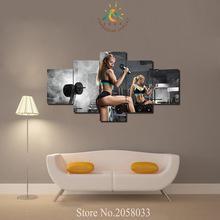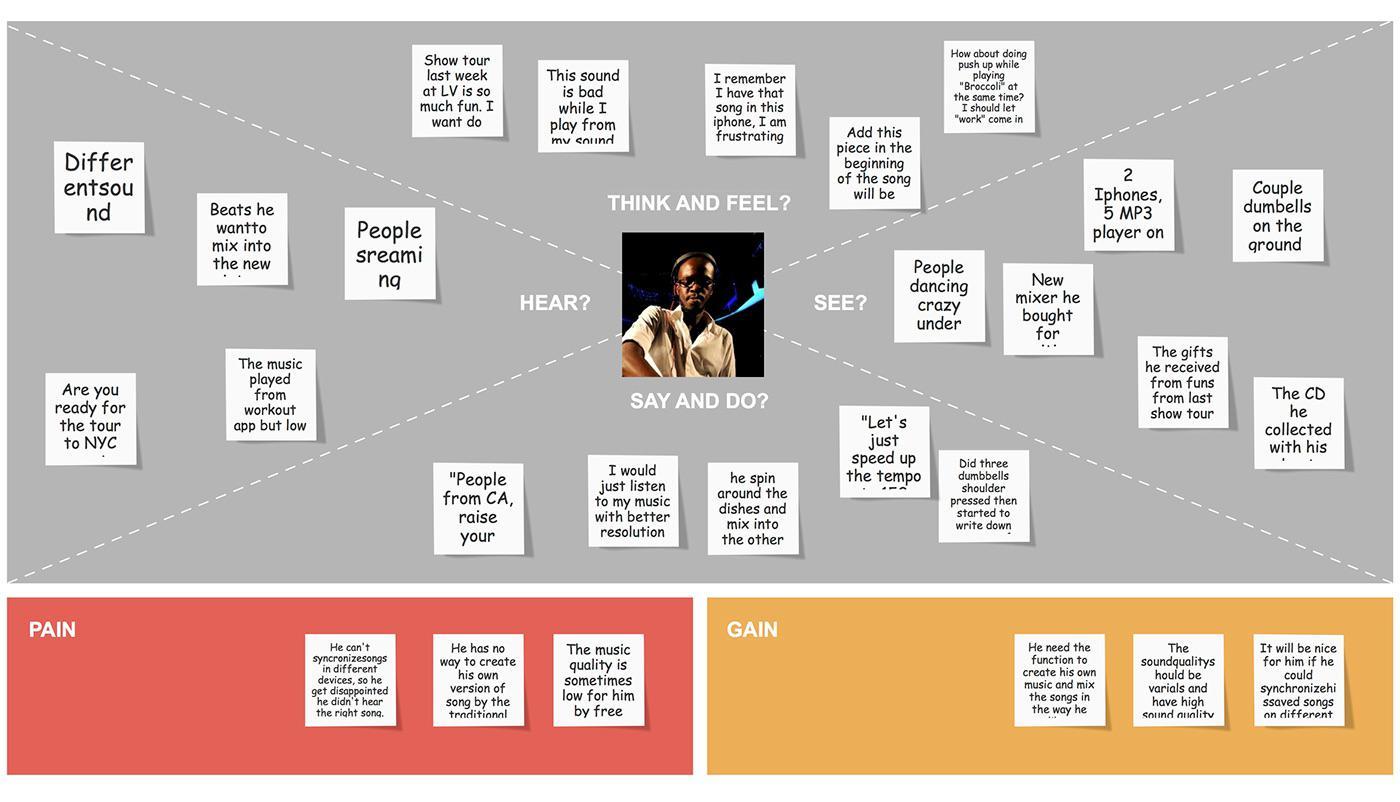The first image is the image on the left, the second image is the image on the right. Assess this claim about the two images: "In one of the images there are three dumbbells of varying sizes arranged in a line.". Correct or not? Answer yes or no. No. 